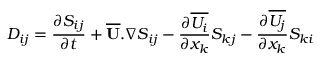Convert formula to latex. <formula><loc_0><loc_0><loc_500><loc_500>D _ { i j } = { \frac { \partial S _ { i j } } { \partial t } } + \overline { U } . \nabla S _ { i j } - { \frac { \partial \overline { { U _ { i } } } } { \partial x _ { k } } } S _ { k j } - { \frac { \partial \overline { { U _ { j } } } } { \partial x _ { k } } } S _ { k i }</formula> 